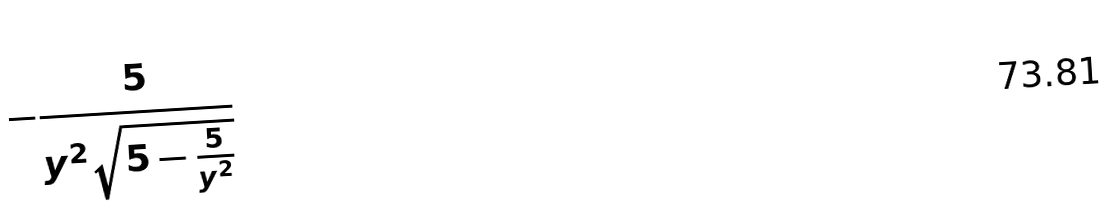<formula> <loc_0><loc_0><loc_500><loc_500>- \frac { 5 } { y ^ { 2 } \sqrt { 5 - \frac { 5 } { y ^ { 2 } } } }</formula> 